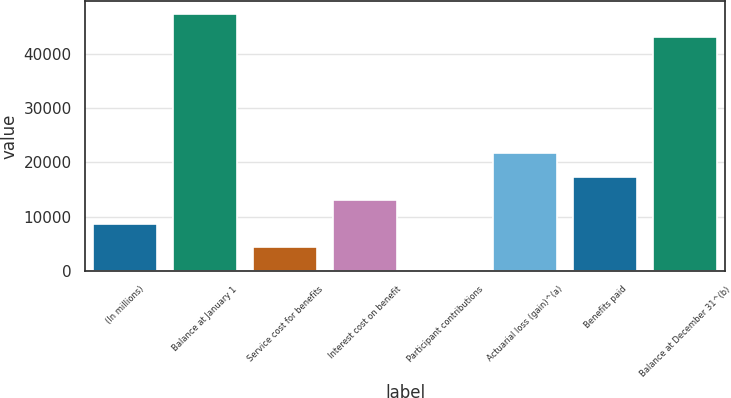Convert chart to OTSL. <chart><loc_0><loc_0><loc_500><loc_500><bar_chart><fcel>(In millions)<fcel>Balance at January 1<fcel>Service cost for benefits<fcel>Interest cost on benefit<fcel>Participant contributions<fcel>Actuarial loss (gain)^(a)<fcel>Benefits paid<fcel>Balance at December 31^(b)<nl><fcel>8797<fcel>47259<fcel>4485<fcel>13109<fcel>173<fcel>21733<fcel>17421<fcel>42947<nl></chart> 